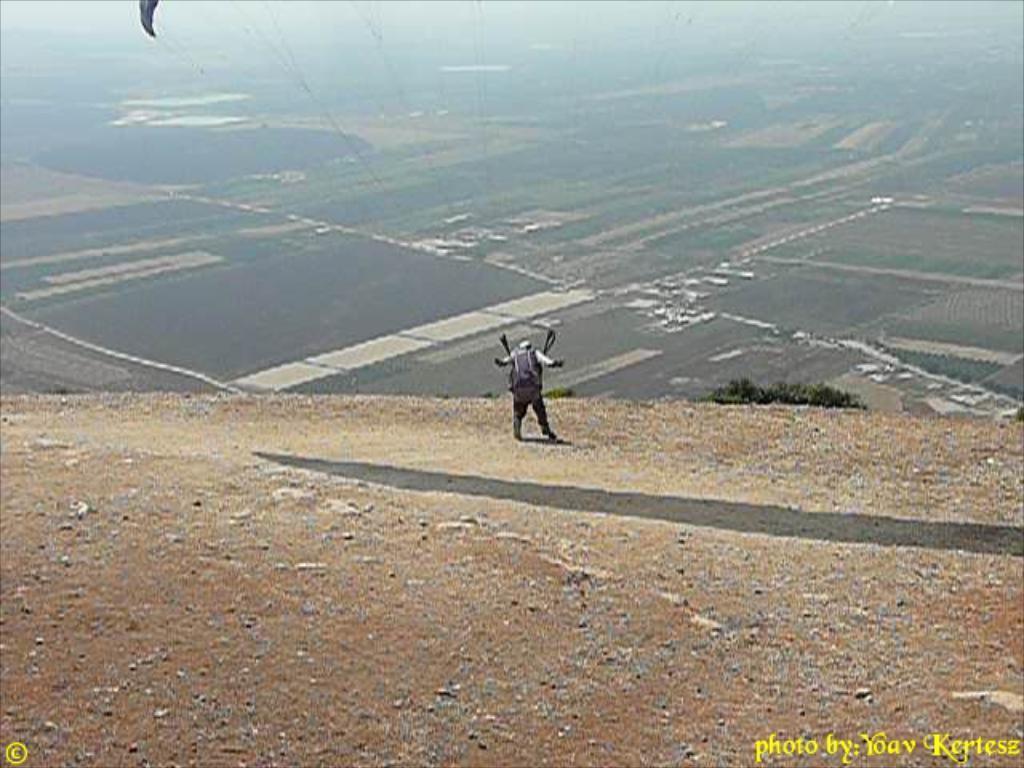What is the main subject of the image? There is a person standing in the image. Where is the person standing? The person is standing on the ground. What can be seen in the background of the image? Fields and the sky are visible in the background of the image. What type of noise can be heard coming from the person's grandfather in the image? There is no mention of a grandfather or any noise in the image, so it cannot be determined. 